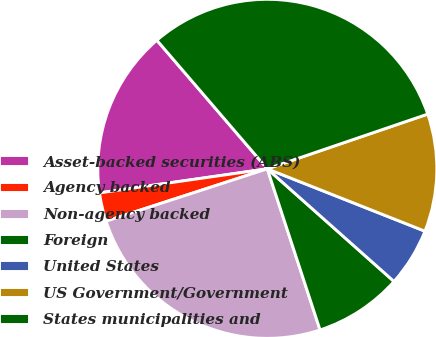<chart> <loc_0><loc_0><loc_500><loc_500><pie_chart><fcel>Asset-backed securities (ABS)<fcel>Agency backed<fcel>Non-agency backed<fcel>Foreign<fcel>United States<fcel>US Government/Government<fcel>States municipalities and<nl><fcel>15.97%<fcel>2.73%<fcel>25.04%<fcel>8.4%<fcel>5.57%<fcel>11.23%<fcel>31.06%<nl></chart> 